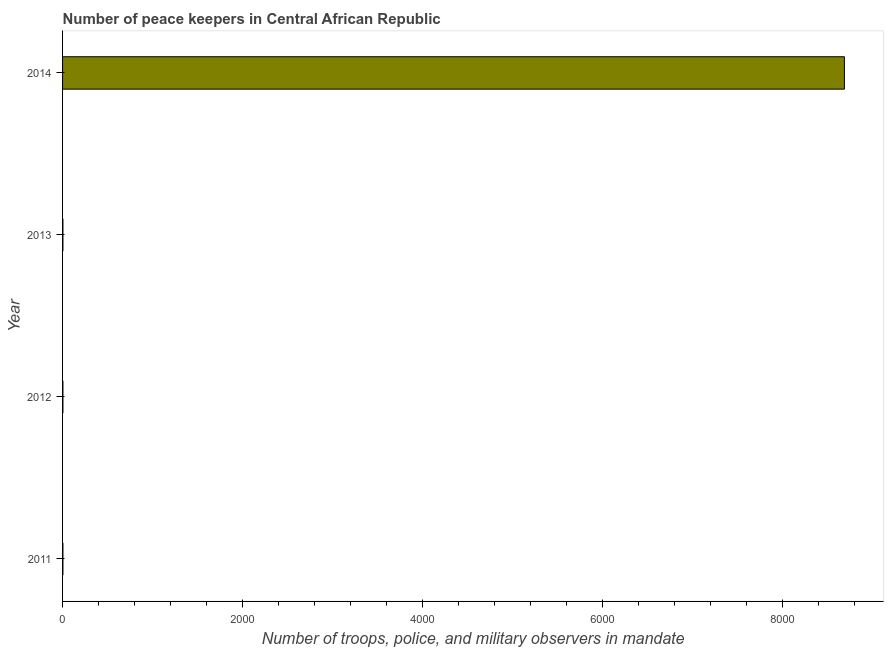Does the graph contain any zero values?
Ensure brevity in your answer.  No. Does the graph contain grids?
Keep it short and to the point. No. What is the title of the graph?
Your answer should be compact. Number of peace keepers in Central African Republic. What is the label or title of the X-axis?
Ensure brevity in your answer.  Number of troops, police, and military observers in mandate. What is the label or title of the Y-axis?
Keep it short and to the point. Year. What is the number of peace keepers in 2014?
Keep it short and to the point. 8685. Across all years, what is the maximum number of peace keepers?
Make the answer very short. 8685. What is the sum of the number of peace keepers?
Give a very brief answer. 8697. What is the average number of peace keepers per year?
Offer a very short reply. 2174. What is the median number of peace keepers?
Your response must be concise. 4. In how many years, is the number of peace keepers greater than 4000 ?
Your answer should be compact. 1. Do a majority of the years between 2013 and 2012 (inclusive) have number of peace keepers greater than 3200 ?
Your response must be concise. No. What is the ratio of the number of peace keepers in 2011 to that in 2013?
Offer a very short reply. 1. Is the number of peace keepers in 2013 less than that in 2014?
Your response must be concise. Yes. Is the difference between the number of peace keepers in 2011 and 2012 greater than the difference between any two years?
Your answer should be compact. No. What is the difference between the highest and the second highest number of peace keepers?
Offer a terse response. 8681. Is the sum of the number of peace keepers in 2013 and 2014 greater than the maximum number of peace keepers across all years?
Offer a very short reply. Yes. What is the difference between the highest and the lowest number of peace keepers?
Your response must be concise. 8681. Are all the bars in the graph horizontal?
Make the answer very short. Yes. What is the Number of troops, police, and military observers in mandate in 2011?
Keep it short and to the point. 4. What is the Number of troops, police, and military observers in mandate of 2013?
Ensure brevity in your answer.  4. What is the Number of troops, police, and military observers in mandate in 2014?
Offer a terse response. 8685. What is the difference between the Number of troops, police, and military observers in mandate in 2011 and 2012?
Provide a succinct answer. 0. What is the difference between the Number of troops, police, and military observers in mandate in 2011 and 2013?
Your answer should be compact. 0. What is the difference between the Number of troops, police, and military observers in mandate in 2011 and 2014?
Ensure brevity in your answer.  -8681. What is the difference between the Number of troops, police, and military observers in mandate in 2012 and 2014?
Keep it short and to the point. -8681. What is the difference between the Number of troops, police, and military observers in mandate in 2013 and 2014?
Provide a succinct answer. -8681. What is the ratio of the Number of troops, police, and military observers in mandate in 2011 to that in 2012?
Provide a short and direct response. 1. What is the ratio of the Number of troops, police, and military observers in mandate in 2011 to that in 2013?
Ensure brevity in your answer.  1. What is the ratio of the Number of troops, police, and military observers in mandate in 2011 to that in 2014?
Give a very brief answer. 0. What is the ratio of the Number of troops, police, and military observers in mandate in 2012 to that in 2013?
Provide a succinct answer. 1. What is the ratio of the Number of troops, police, and military observers in mandate in 2013 to that in 2014?
Your response must be concise. 0. 